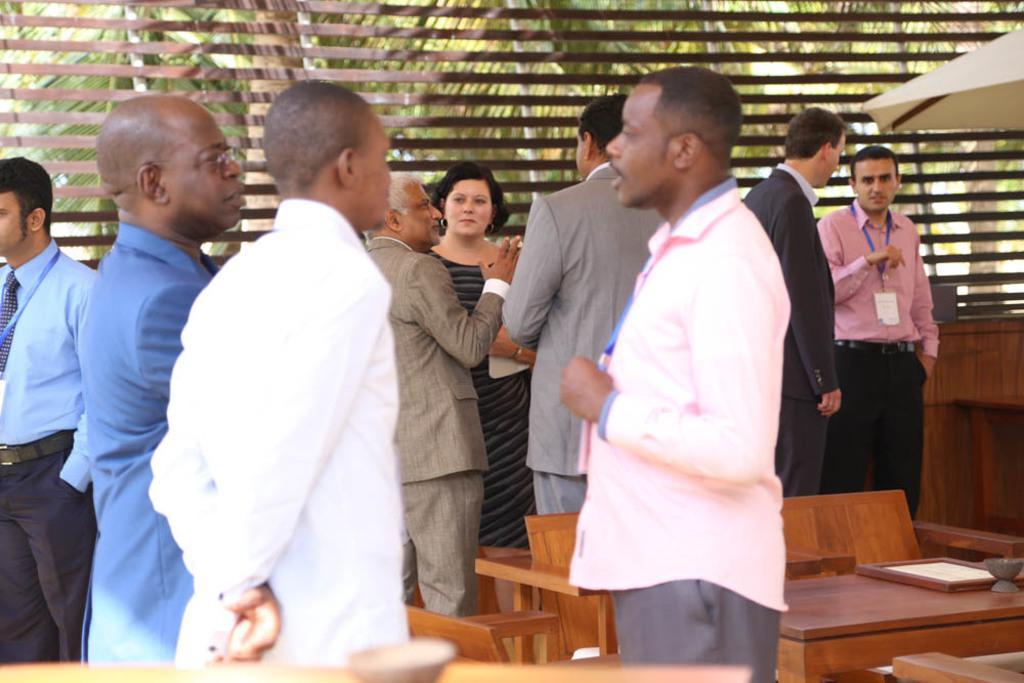Please provide a concise description of this image. In this image we can see a group of people standing on the ground. One woman is holding an object in her hand. In the foreground we can see some chairs, a table containing frame and a bowl on it. In the right side of the image we can see an umbrella. In the background, we can see some some poles and group of trees. 